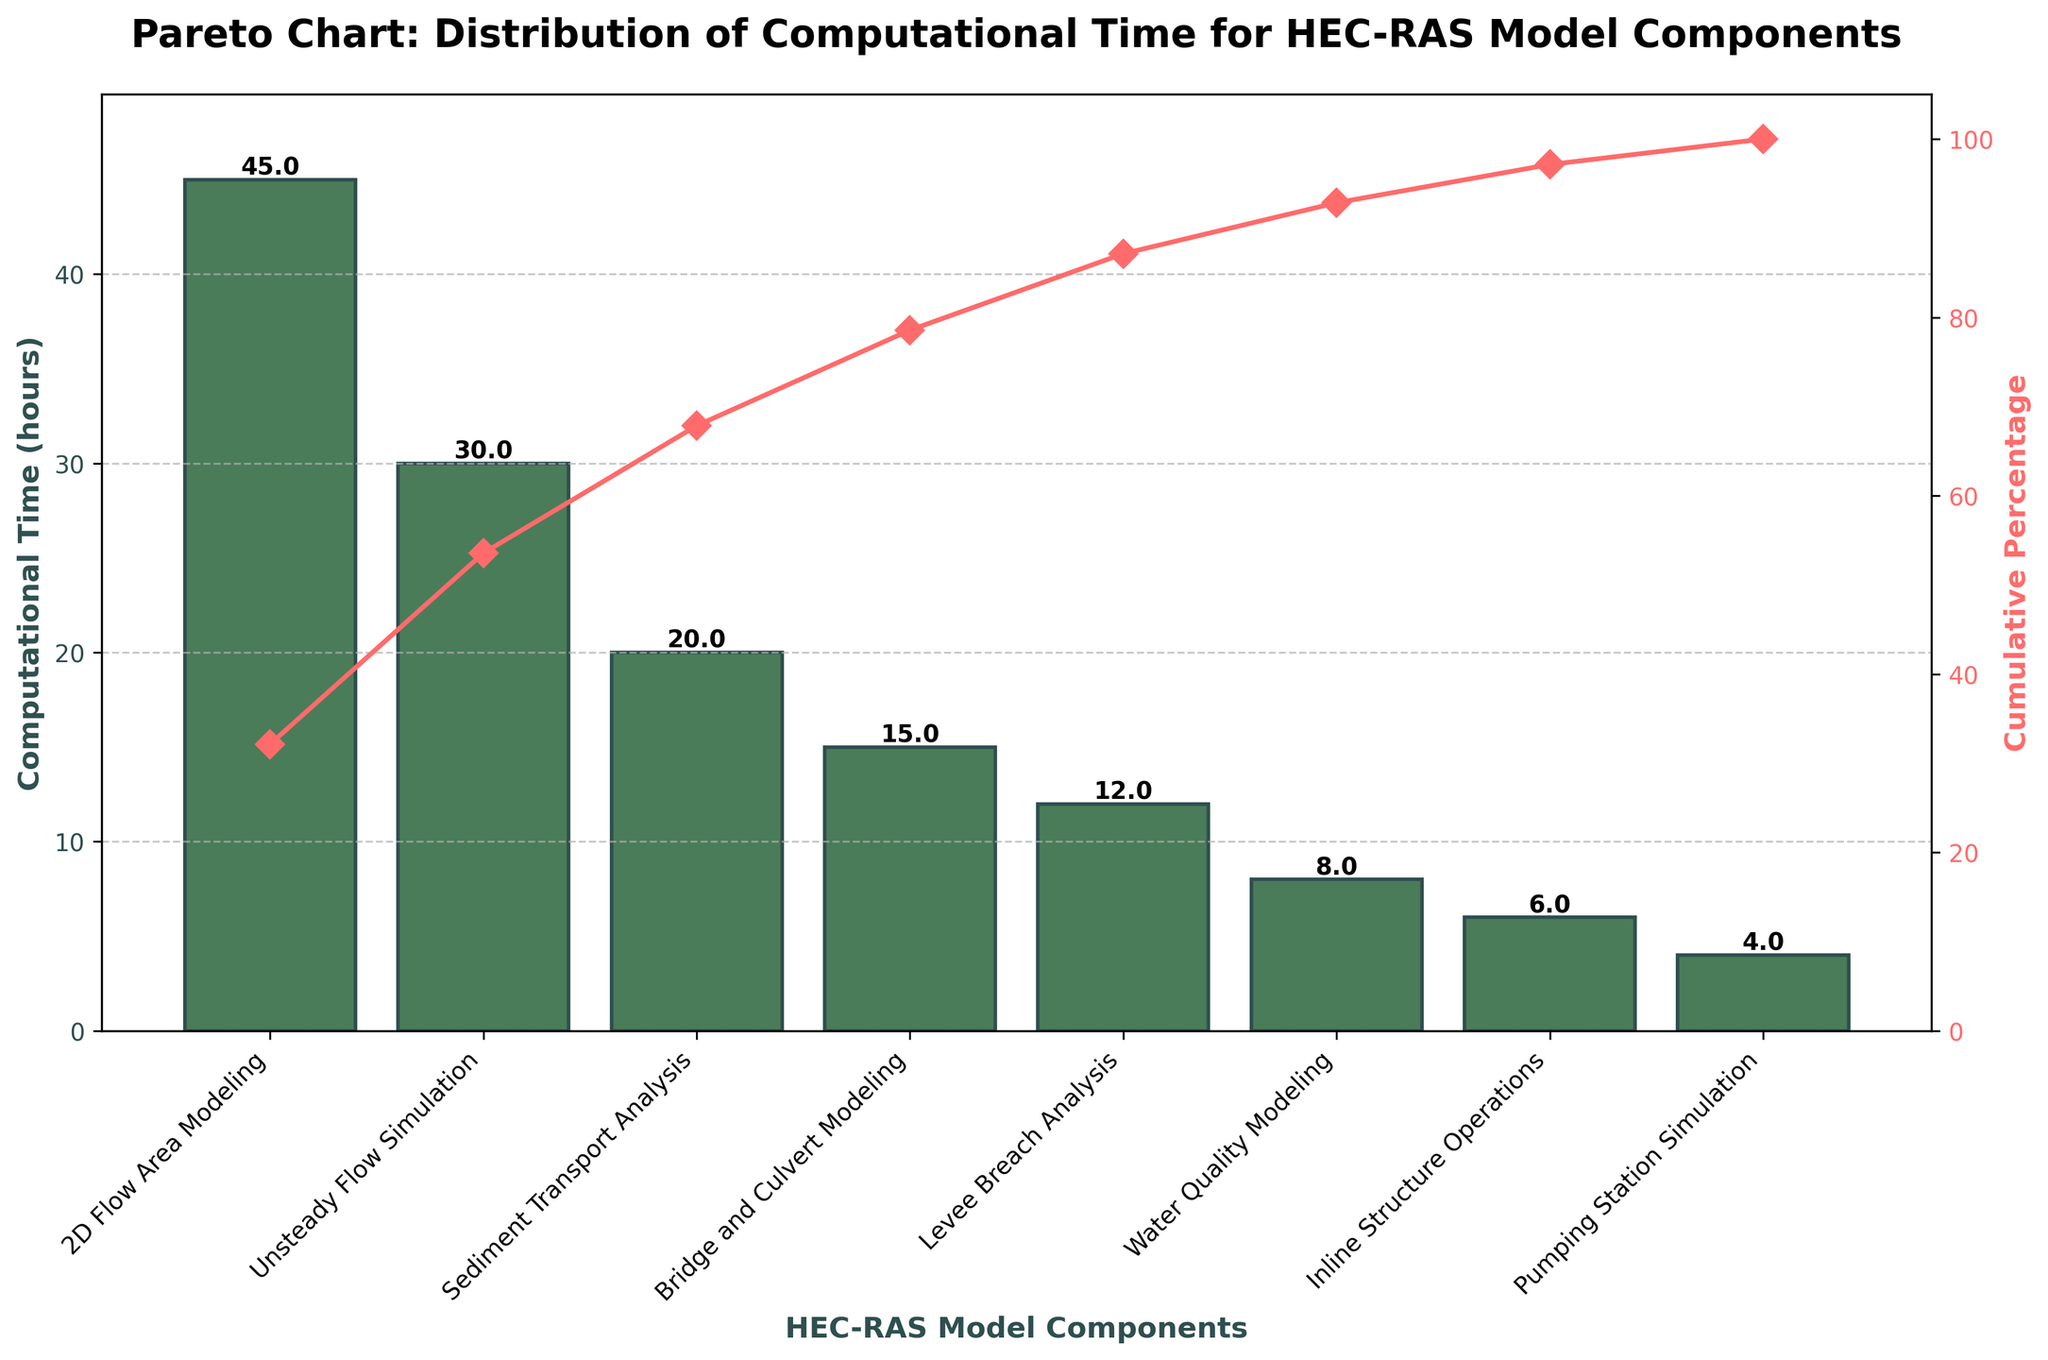What is the title of the figure? The title of the figure is shown at the top of the chart. It reads "Pareto Chart: Distribution of Computational Time for HEC-RAS Model Components".
Answer: Pareto Chart: Distribution of Computational Time for HEC-RAS Model Components What are the two y-axes representing in the chart? The left y-axis represents Computational Time in hours, while the right y-axis represents the Cumulative Percentage of computational time.
Answer: Computational Time and Cumulative Percentage Which HEC-RAS model component has the highest computational time? The bar chart shows that the highest bar is for "2D Flow Area Modeling".
Answer: 2D Flow Area Modeling What is the computational time for Unsteady Flow Simulation? The bar for "Unsteady Flow Simulation" has a label on top of it indicating its height. It reads "30", which represents 30 hours.
Answer: 30 hours Add up the computational times for Sediment Transport Analysis and Bridge and Culvert Modeling. What is the total? Sediment Transport Analysis has 20 hours and Bridge and Culvert Modeling has 15 hours. Adding them together: 20 + 15 = 35 hours.
Answer: 35 hours Which component contributes to reaching just over 65% cumulative percentage? The cumulative percentage curve reaches just over 65% at "Bridge and Culvert Modeling".
Answer: Bridge and Culvert Modeling Compare the computational times of Levee Breach Analysis and Water Quality Modeling. Which one is higher? The bar for Levee Breach Analysis is higher than the bar for Water Quality Modeling, indicating 12 hours compared to 8 hours.
Answer: Levee Breach Analysis How many HEC-RAS model components account for approximately 80% of the total computational time? By examining the cumulative percentage curve, it reaches approximately 80% after "Levee Breach Analysis", which includes the first 5 components.
Answer: 5 components What is the cumulative percentage after the first three components? The cumulative percentage curve intersects just over 70% after the third component, which is "Sediment Transport Analysis".
Answer: Just over 70% What is the last component listed in the Pareto chart and its computational time? The last bar on the chart corresponds to "Pumping Station Simulation" with a computational time label of 4 hours.
Answer: Pumping Station Simulation, 4 hours 